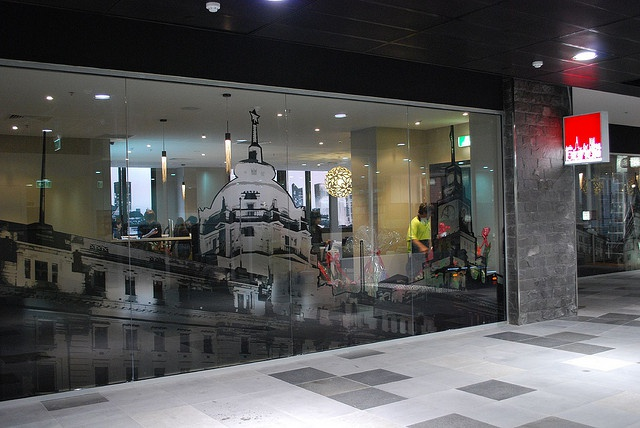Describe the objects in this image and their specific colors. I can see people in black and olive tones, people in black, gray, purple, and darkblue tones, people in black and gray tones, dining table in black, gray, and tan tones, and people in black and purple tones in this image. 